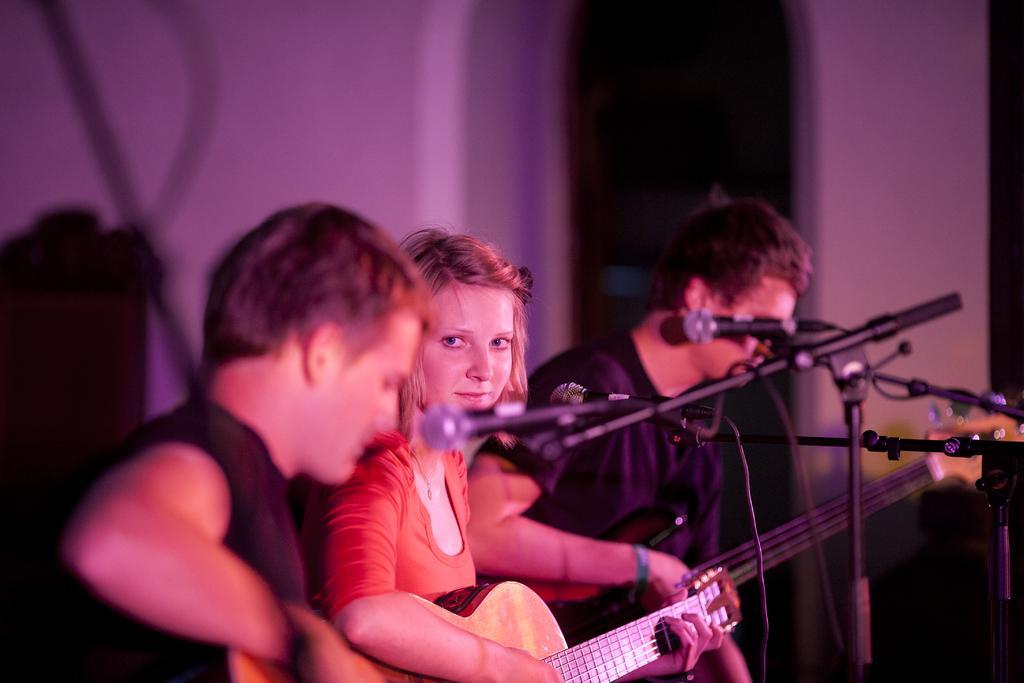Describe this image in one or two sentences. In the image there are three people in which the girl in the middle is playing the guitar and while the other two men are also playing the guitar. There are three mics in front of them. At the background there is wall. 